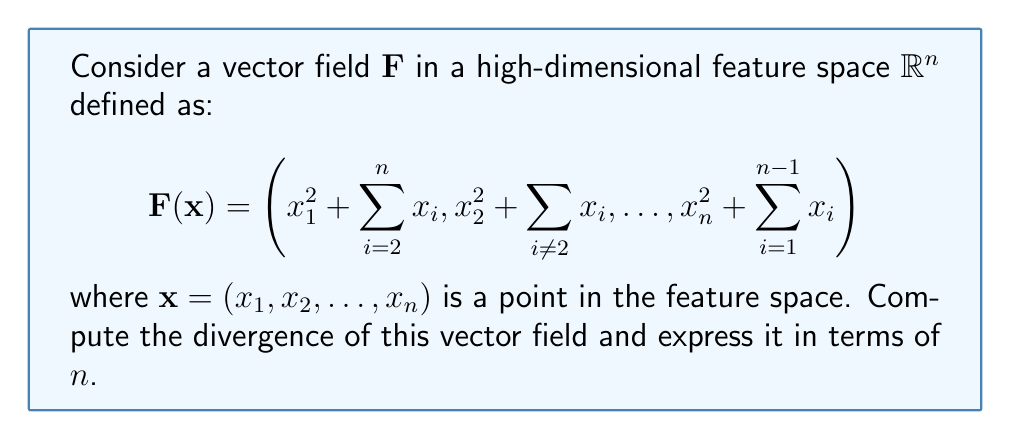Can you answer this question? To compute the divergence of the vector field $\mathbf{F}$, we need to follow these steps:

1) Recall that the divergence of a vector field $\mathbf{F} = (F_1, F_2, \ldots, F_n)$ in $\mathbb{R}^n$ is given by:

   $$\nabla \cdot \mathbf{F} = \sum_{i=1}^n \frac{\partial F_i}{\partial x_i}$$

2) Let's compute each partial derivative $\frac{\partial F_i}{\partial x_i}$:

   For $i = 1$:
   $$\frac{\partial F_1}{\partial x_1} = \frac{\partial}{\partial x_1}\left(x_1^2 + \sum_{i=2}^n x_i\right) = 2x_1$$

   For $i = 2$:
   $$\frac{\partial F_2}{\partial x_2} = \frac{\partial}{\partial x_2}\left(x_2^2 + \sum_{i\neq 2} x_i\right) = 2x_2$$

   This pattern continues for all $i$ up to $n$, so in general:
   $$\frac{\partial F_i}{\partial x_i} = 2x_i$$

3) Now, we sum all these partial derivatives:

   $$\nabla \cdot \mathbf{F} = \sum_{i=1}^n \frac{\partial F_i}{\partial x_i} = \sum_{i=1}^n 2x_i = 2\sum_{i=1}^n x_i$$

4) However, we need to express this in terms of $n$, not the individual $x_i$ values. Let's look at the structure of $\mathbf{F}$ again:

   Each component $F_i$ includes the term $\sum_{j\neq i} x_j$, which is the sum of all $x_j$ except $x_i$.

5) If we sum all components of $\mathbf{F}$, each $x_i$ will appear $n-1$ times in these summations, plus once more as $x_i^2$. Therefore:

   $$\sum_{i=1}^n F_i = \sum_{i=1}^n x_i^2 + (n-1)\sum_{i=1}^n x_i$$

6) From this, we can deduce that:

   $$2\sum_{i=1}^n x_i = 2n$$

Therefore, the divergence of $\mathbf{F}$ is constant and equal to $2n$.
Answer: The divergence of the vector field $\mathbf{F}$ is $2n$, where $n$ is the dimension of the feature space. 